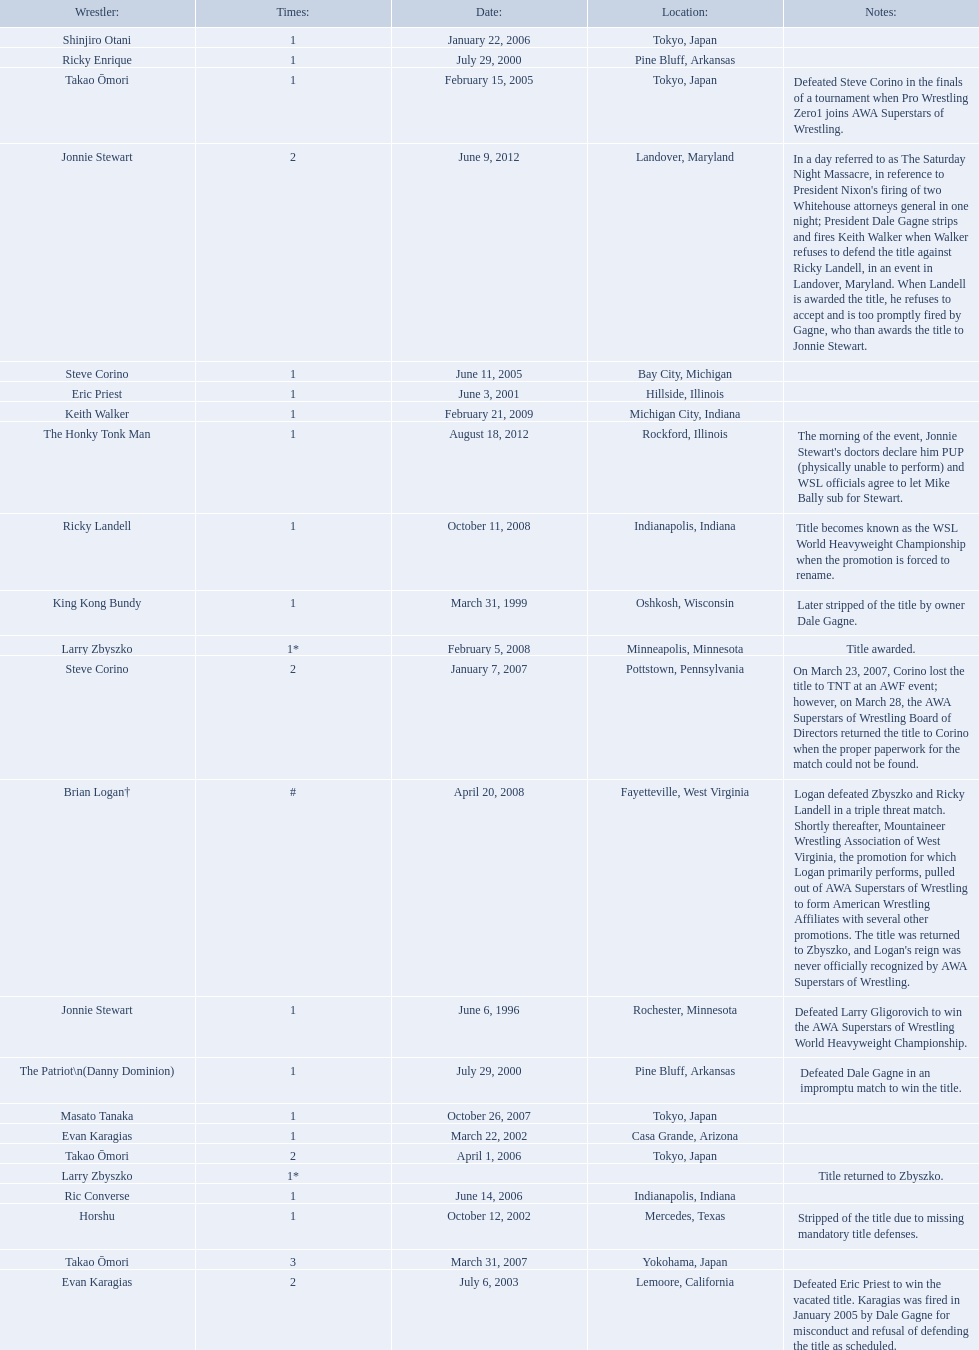Who are the wrestlers? Jonnie Stewart, Rochester, Minnesota, King Kong Bundy, Oshkosh, Wisconsin, The Patriot\n(Danny Dominion), Pine Bluff, Arkansas, Ricky Enrique, Pine Bluff, Arkansas, Eric Priest, Hillside, Illinois, Evan Karagias, Casa Grande, Arizona, Horshu, Mercedes, Texas, Evan Karagias, Lemoore, California, Takao Ōmori, Tokyo, Japan, Steve Corino, Bay City, Michigan, Shinjiro Otani, Tokyo, Japan, Takao Ōmori, Tokyo, Japan, Ric Converse, Indianapolis, Indiana, Steve Corino, Pottstown, Pennsylvania, Takao Ōmori, Yokohama, Japan, Masato Tanaka, Tokyo, Japan, Larry Zbyszko, Minneapolis, Minnesota, Brian Logan†, Fayetteville, West Virginia, Larry Zbyszko, , Ricky Landell, Indianapolis, Indiana, Keith Walker, Michigan City, Indiana, Jonnie Stewart, Landover, Maryland, The Honky Tonk Man, Rockford, Illinois. Who was from texas? Horshu, Mercedes, Texas. Who is he? Horshu. 